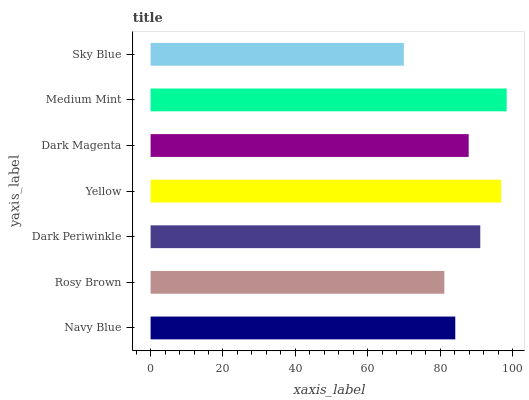Is Sky Blue the minimum?
Answer yes or no. Yes. Is Medium Mint the maximum?
Answer yes or no. Yes. Is Rosy Brown the minimum?
Answer yes or no. No. Is Rosy Brown the maximum?
Answer yes or no. No. Is Navy Blue greater than Rosy Brown?
Answer yes or no. Yes. Is Rosy Brown less than Navy Blue?
Answer yes or no. Yes. Is Rosy Brown greater than Navy Blue?
Answer yes or no. No. Is Navy Blue less than Rosy Brown?
Answer yes or no. No. Is Dark Magenta the high median?
Answer yes or no. Yes. Is Dark Magenta the low median?
Answer yes or no. Yes. Is Dark Periwinkle the high median?
Answer yes or no. No. Is Yellow the low median?
Answer yes or no. No. 